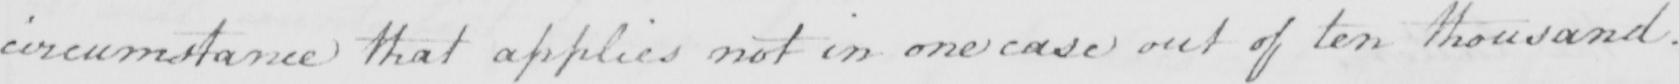What is written in this line of handwriting? circumstance that applies not in one case out of ten thousand . 